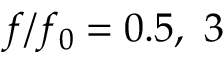<formula> <loc_0><loc_0><loc_500><loc_500>f / f _ { 0 } = 0 . 5 , \ 3</formula> 